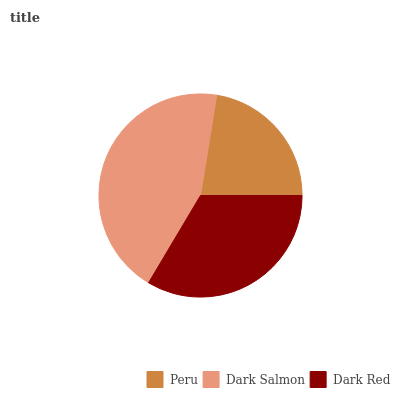Is Peru the minimum?
Answer yes or no. Yes. Is Dark Salmon the maximum?
Answer yes or no. Yes. Is Dark Red the minimum?
Answer yes or no. No. Is Dark Red the maximum?
Answer yes or no. No. Is Dark Salmon greater than Dark Red?
Answer yes or no. Yes. Is Dark Red less than Dark Salmon?
Answer yes or no. Yes. Is Dark Red greater than Dark Salmon?
Answer yes or no. No. Is Dark Salmon less than Dark Red?
Answer yes or no. No. Is Dark Red the high median?
Answer yes or no. Yes. Is Dark Red the low median?
Answer yes or no. Yes. Is Dark Salmon the high median?
Answer yes or no. No. Is Dark Salmon the low median?
Answer yes or no. No. 